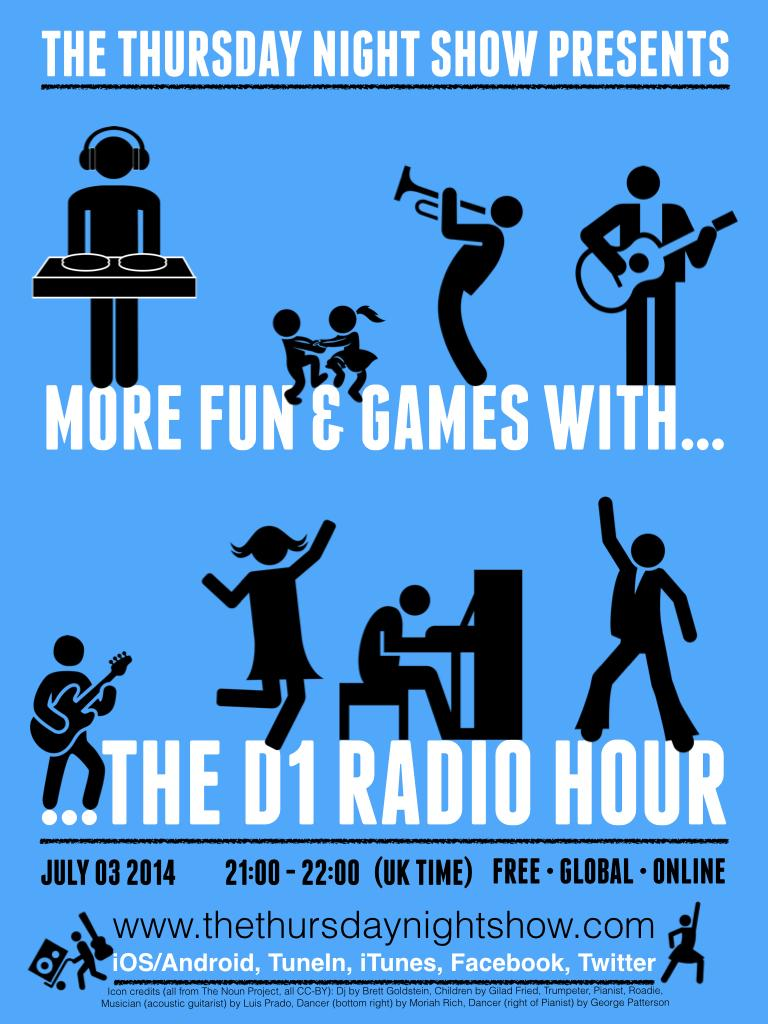What is shown in the image? There are depictions of a person in the image. What else can be found in the image? There is text in the image. What sound can be heard coming from the lunchroom in the image? There is no lunchroom present in the image, so it's not possible to determine what sound might be heard. 